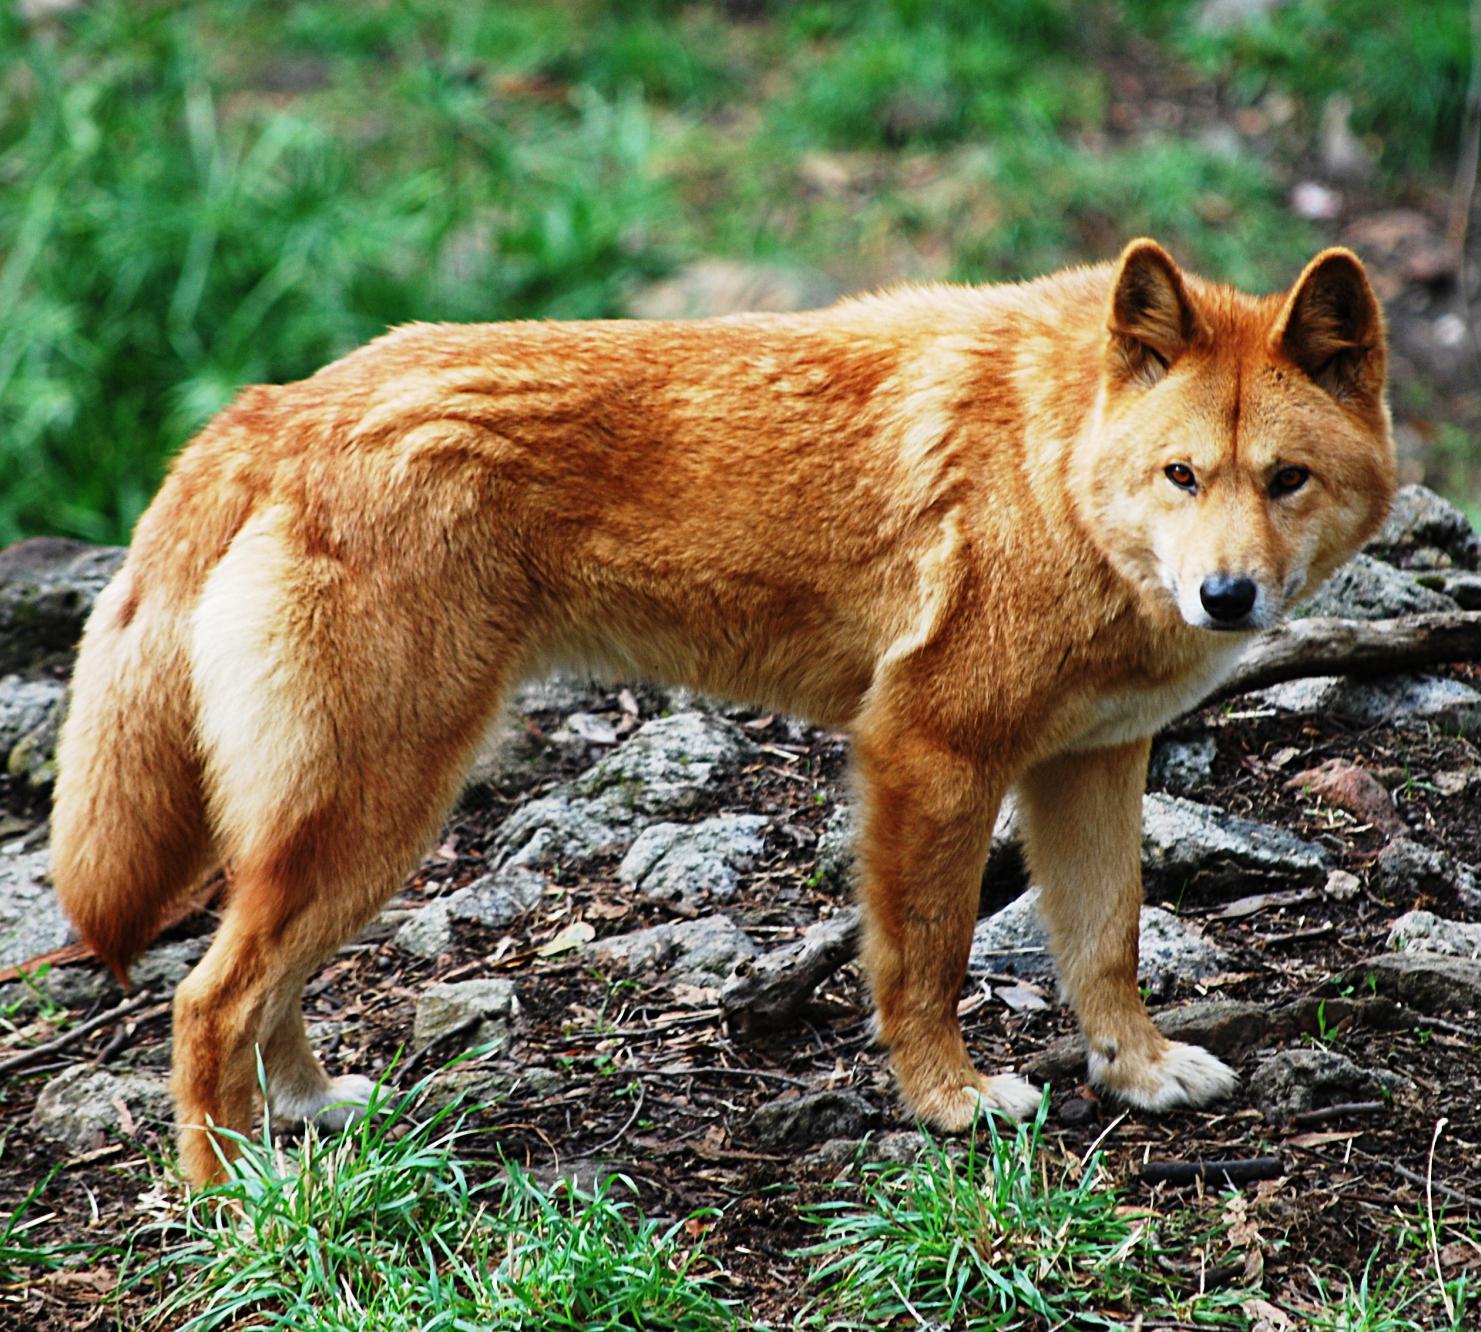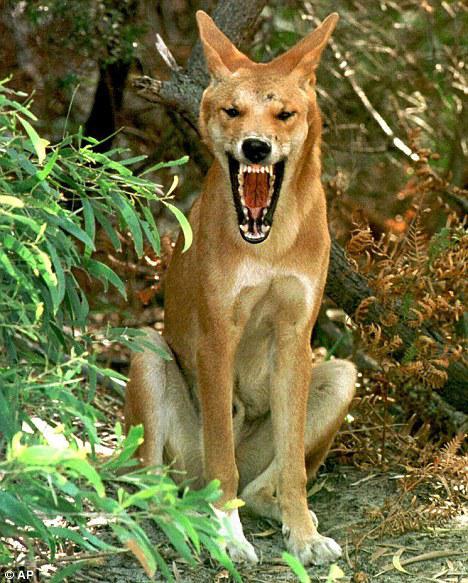The first image is the image on the left, the second image is the image on the right. For the images shown, is this caption "The wild dog in the image on the left is lying on the ground." true? Answer yes or no. No. 